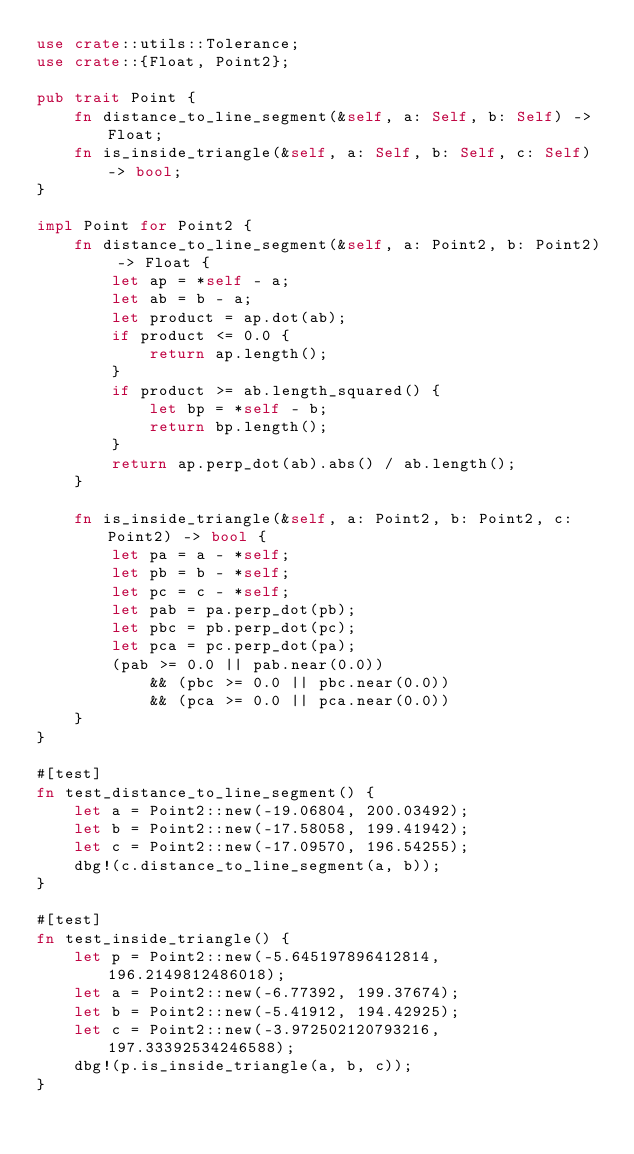<code> <loc_0><loc_0><loc_500><loc_500><_Rust_>use crate::utils::Tolerance;
use crate::{Float, Point2};

pub trait Point {
    fn distance_to_line_segment(&self, a: Self, b: Self) -> Float;
    fn is_inside_triangle(&self, a: Self, b: Self, c: Self) -> bool;
}

impl Point for Point2 {
    fn distance_to_line_segment(&self, a: Point2, b: Point2) -> Float {
        let ap = *self - a;
        let ab = b - a;
        let product = ap.dot(ab);
        if product <= 0.0 {
            return ap.length();
        }
        if product >= ab.length_squared() {
            let bp = *self - b;
            return bp.length();
        }
        return ap.perp_dot(ab).abs() / ab.length();
    }

    fn is_inside_triangle(&self, a: Point2, b: Point2, c: Point2) -> bool {
        let pa = a - *self;
        let pb = b - *self;
        let pc = c - *self;
        let pab = pa.perp_dot(pb);
        let pbc = pb.perp_dot(pc);
        let pca = pc.perp_dot(pa);
        (pab >= 0.0 || pab.near(0.0))
            && (pbc >= 0.0 || pbc.near(0.0))
            && (pca >= 0.0 || pca.near(0.0))
    }
}

#[test]
fn test_distance_to_line_segment() {
    let a = Point2::new(-19.06804, 200.03492);
    let b = Point2::new(-17.58058, 199.41942);
    let c = Point2::new(-17.09570, 196.54255);
    dbg!(c.distance_to_line_segment(a, b));
}

#[test]
fn test_inside_triangle() {
    let p = Point2::new(-5.645197896412814, 196.2149812486018);
    let a = Point2::new(-6.77392, 199.37674);
    let b = Point2::new(-5.41912, 194.42925);
    let c = Point2::new(-3.972502120793216, 197.33392534246588);
    dbg!(p.is_inside_triangle(a, b, c));
}
</code> 